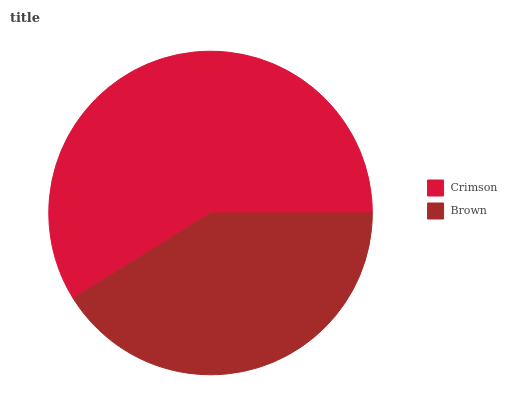Is Brown the minimum?
Answer yes or no. Yes. Is Crimson the maximum?
Answer yes or no. Yes. Is Brown the maximum?
Answer yes or no. No. Is Crimson greater than Brown?
Answer yes or no. Yes. Is Brown less than Crimson?
Answer yes or no. Yes. Is Brown greater than Crimson?
Answer yes or no. No. Is Crimson less than Brown?
Answer yes or no. No. Is Crimson the high median?
Answer yes or no. Yes. Is Brown the low median?
Answer yes or no. Yes. Is Brown the high median?
Answer yes or no. No. Is Crimson the low median?
Answer yes or no. No. 